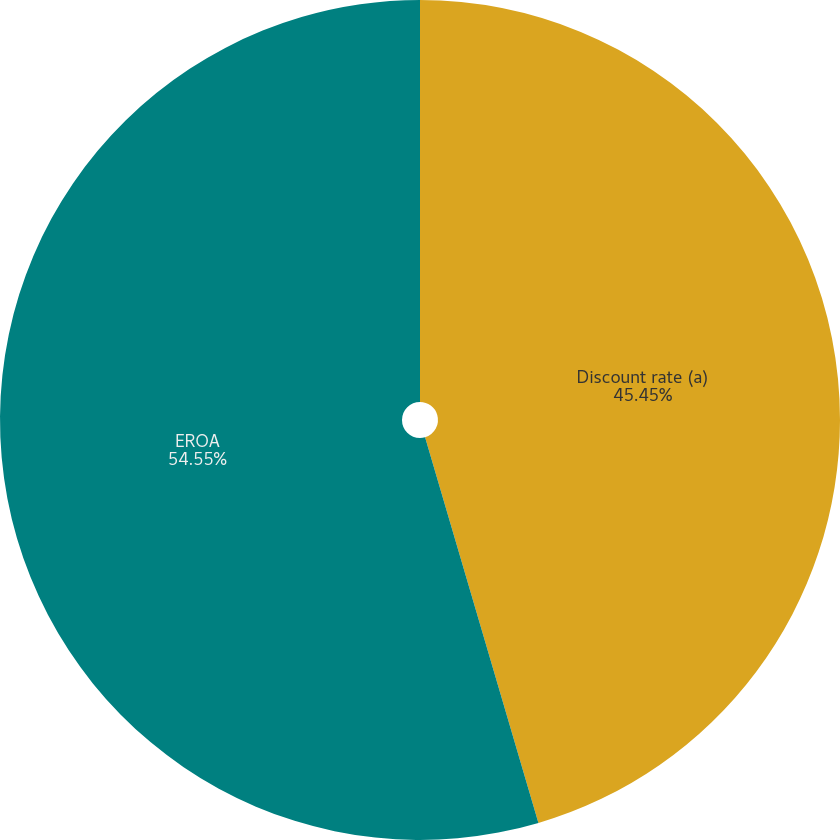Convert chart. <chart><loc_0><loc_0><loc_500><loc_500><pie_chart><fcel>Discount rate (a)<fcel>EROA<nl><fcel>45.45%<fcel>54.55%<nl></chart> 